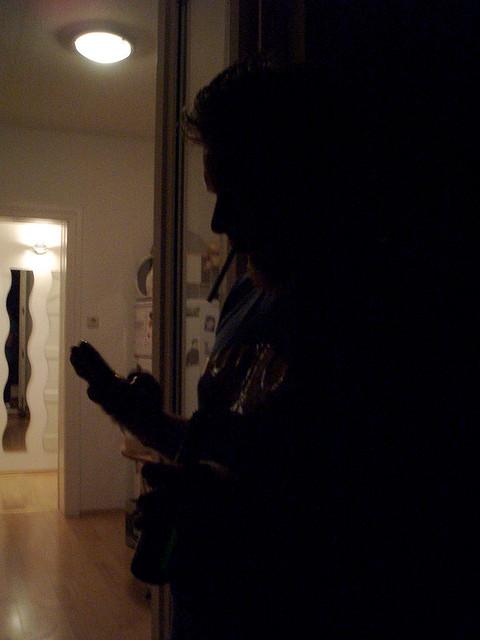Who is standing outside of the sheltered bench?
Concise answer only. Man. Can you see the man clearly?
Be succinct. No. What is this person doing?
Quick response, please. Smoking. Is it light outside?
Short answer required. No. What is the man holding in his mouth?
Be succinct. Cigarette. What color is the person's shirt?
Keep it brief. Black. 